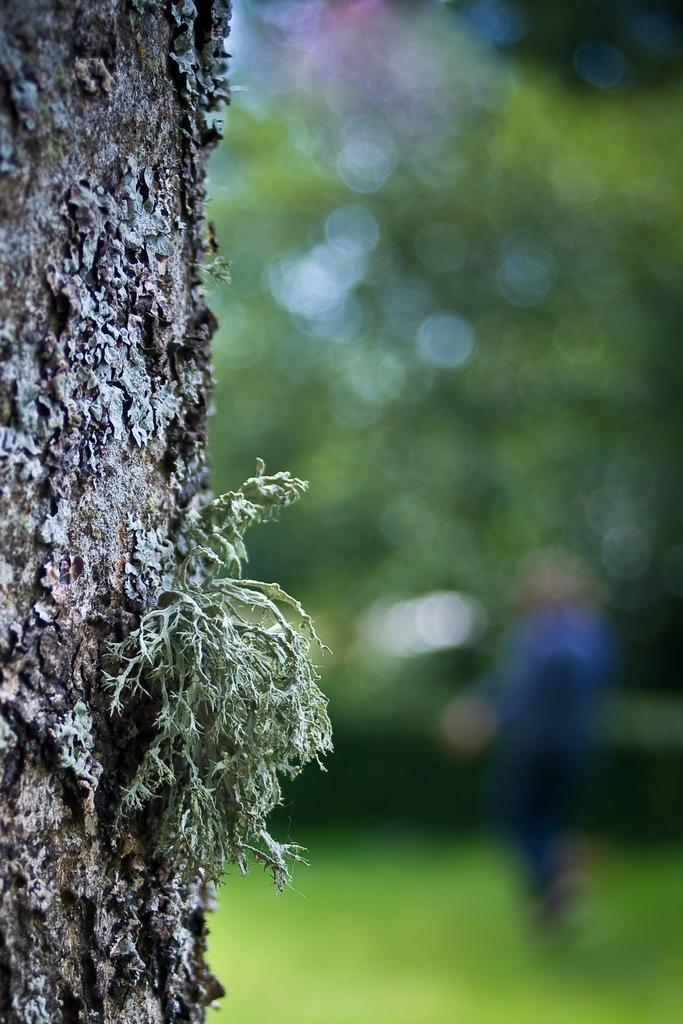What can be seen on the left side of the image? There is a tree trunk on the left side of the image. How would you describe the background of the image? The background of the image is blurred. Where is the shelf located in the image? There is no shelf present in the image. Can you see a plane flying in the background of the image? There is no plane visible in the image, and the background is blurred, making it difficult to see any details. Is there a deer in the image? There is no deer present in the image. 